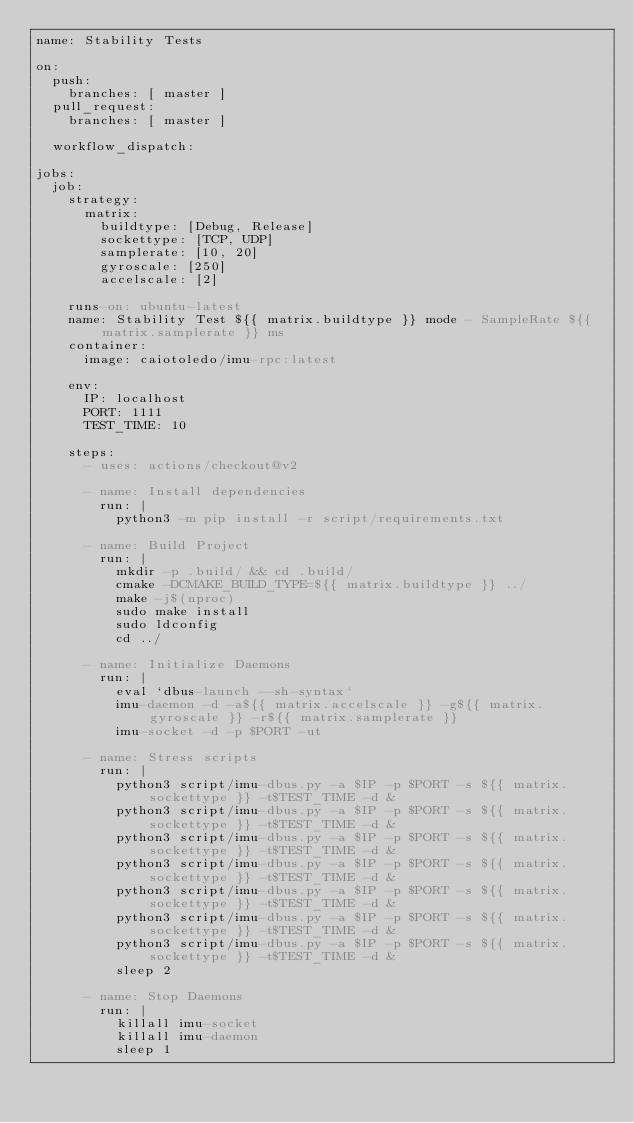Convert code to text. <code><loc_0><loc_0><loc_500><loc_500><_YAML_>name: Stability Tests

on:
  push:
    branches: [ master ]
  pull_request:
    branches: [ master ]

  workflow_dispatch:

jobs:
  job:
    strategy:
      matrix:
        buildtype: [Debug, Release]
        sockettype: [TCP, UDP]
        samplerate: [10, 20]
        gyroscale: [250]
        accelscale: [2]

    runs-on: ubuntu-latest
    name: Stability Test ${{ matrix.buildtype }} mode - SampleRate ${{ matrix.samplerate }} ms
    container:
      image: caiotoledo/imu-rpc:latest

    env:
      IP: localhost
      PORT: 1111
      TEST_TIME: 10

    steps:
      - uses: actions/checkout@v2

      - name: Install dependencies
        run: |
          python3 -m pip install -r script/requirements.txt

      - name: Build Project
        run: |
          mkdir -p .build/ && cd .build/
          cmake -DCMAKE_BUILD_TYPE=${{ matrix.buildtype }} ../
          make -j$(nproc)
          sudo make install
          sudo ldconfig
          cd ../

      - name: Initialize Daemons
        run: |
          eval `dbus-launch --sh-syntax`
          imu-daemon -d -a${{ matrix.accelscale }} -g${{ matrix.gyroscale }} -r${{ matrix.samplerate }}
          imu-socket -d -p $PORT -ut

      - name: Stress scripts
        run: |
          python3 script/imu-dbus.py -a $IP -p $PORT -s ${{ matrix.sockettype }} -t$TEST_TIME -d &
          python3 script/imu-dbus.py -a $IP -p $PORT -s ${{ matrix.sockettype }} -t$TEST_TIME -d &
          python3 script/imu-dbus.py -a $IP -p $PORT -s ${{ matrix.sockettype }} -t$TEST_TIME -d &
          python3 script/imu-dbus.py -a $IP -p $PORT -s ${{ matrix.sockettype }} -t$TEST_TIME -d &
          python3 script/imu-dbus.py -a $IP -p $PORT -s ${{ matrix.sockettype }} -t$TEST_TIME -d &
          python3 script/imu-dbus.py -a $IP -p $PORT -s ${{ matrix.sockettype }} -t$TEST_TIME -d &
          python3 script/imu-dbus.py -a $IP -p $PORT -s ${{ matrix.sockettype }} -t$TEST_TIME -d &
          sleep 2

      - name: Stop Daemons
        run: |
          killall imu-socket
          killall imu-daemon
          sleep 1
</code> 